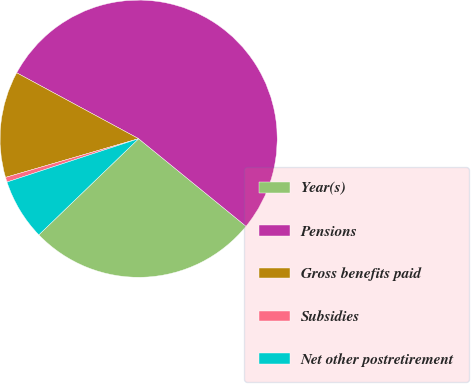Convert chart. <chart><loc_0><loc_0><loc_500><loc_500><pie_chart><fcel>Year(s)<fcel>Pensions<fcel>Gross benefits paid<fcel>Subsidies<fcel>Net other postretirement<nl><fcel>26.91%<fcel>53.0%<fcel>12.39%<fcel>0.56%<fcel>7.14%<nl></chart> 